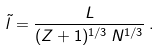Convert formula to latex. <formula><loc_0><loc_0><loc_500><loc_500>\tilde { l } = \frac { L } { ( Z + 1 ) ^ { 1 / 3 } \, N ^ { 1 / 3 } } \, .</formula> 